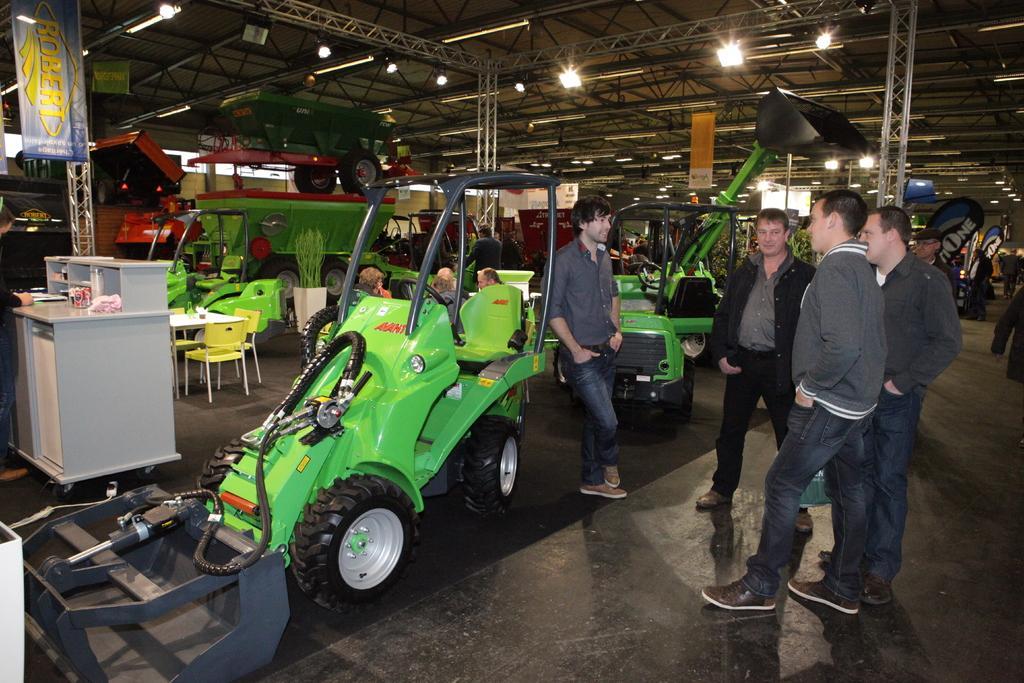In one or two sentences, can you explain what this image depicts? In this image we can see a shed with iron rods, lights and pillars with rods. And there are many vehicles inside the shed. Also there are people. And there are chairs. Also there are banners. And there is a cupboard. On that there are few items. 